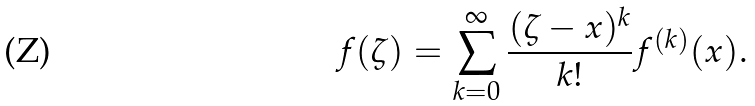<formula> <loc_0><loc_0><loc_500><loc_500>f ( \zeta ) = \sum _ { k = 0 } ^ { \infty } \frac { ( \zeta - x ) ^ { k } } { k ! } f ^ { ( k ) } ( x ) .</formula> 